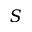Convert formula to latex. <formula><loc_0><loc_0><loc_500><loc_500>S</formula> 